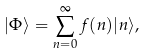Convert formula to latex. <formula><loc_0><loc_0><loc_500><loc_500>| \Phi \rangle = \sum _ { n = 0 } ^ { \infty } f ( n ) | n \rangle ,</formula> 